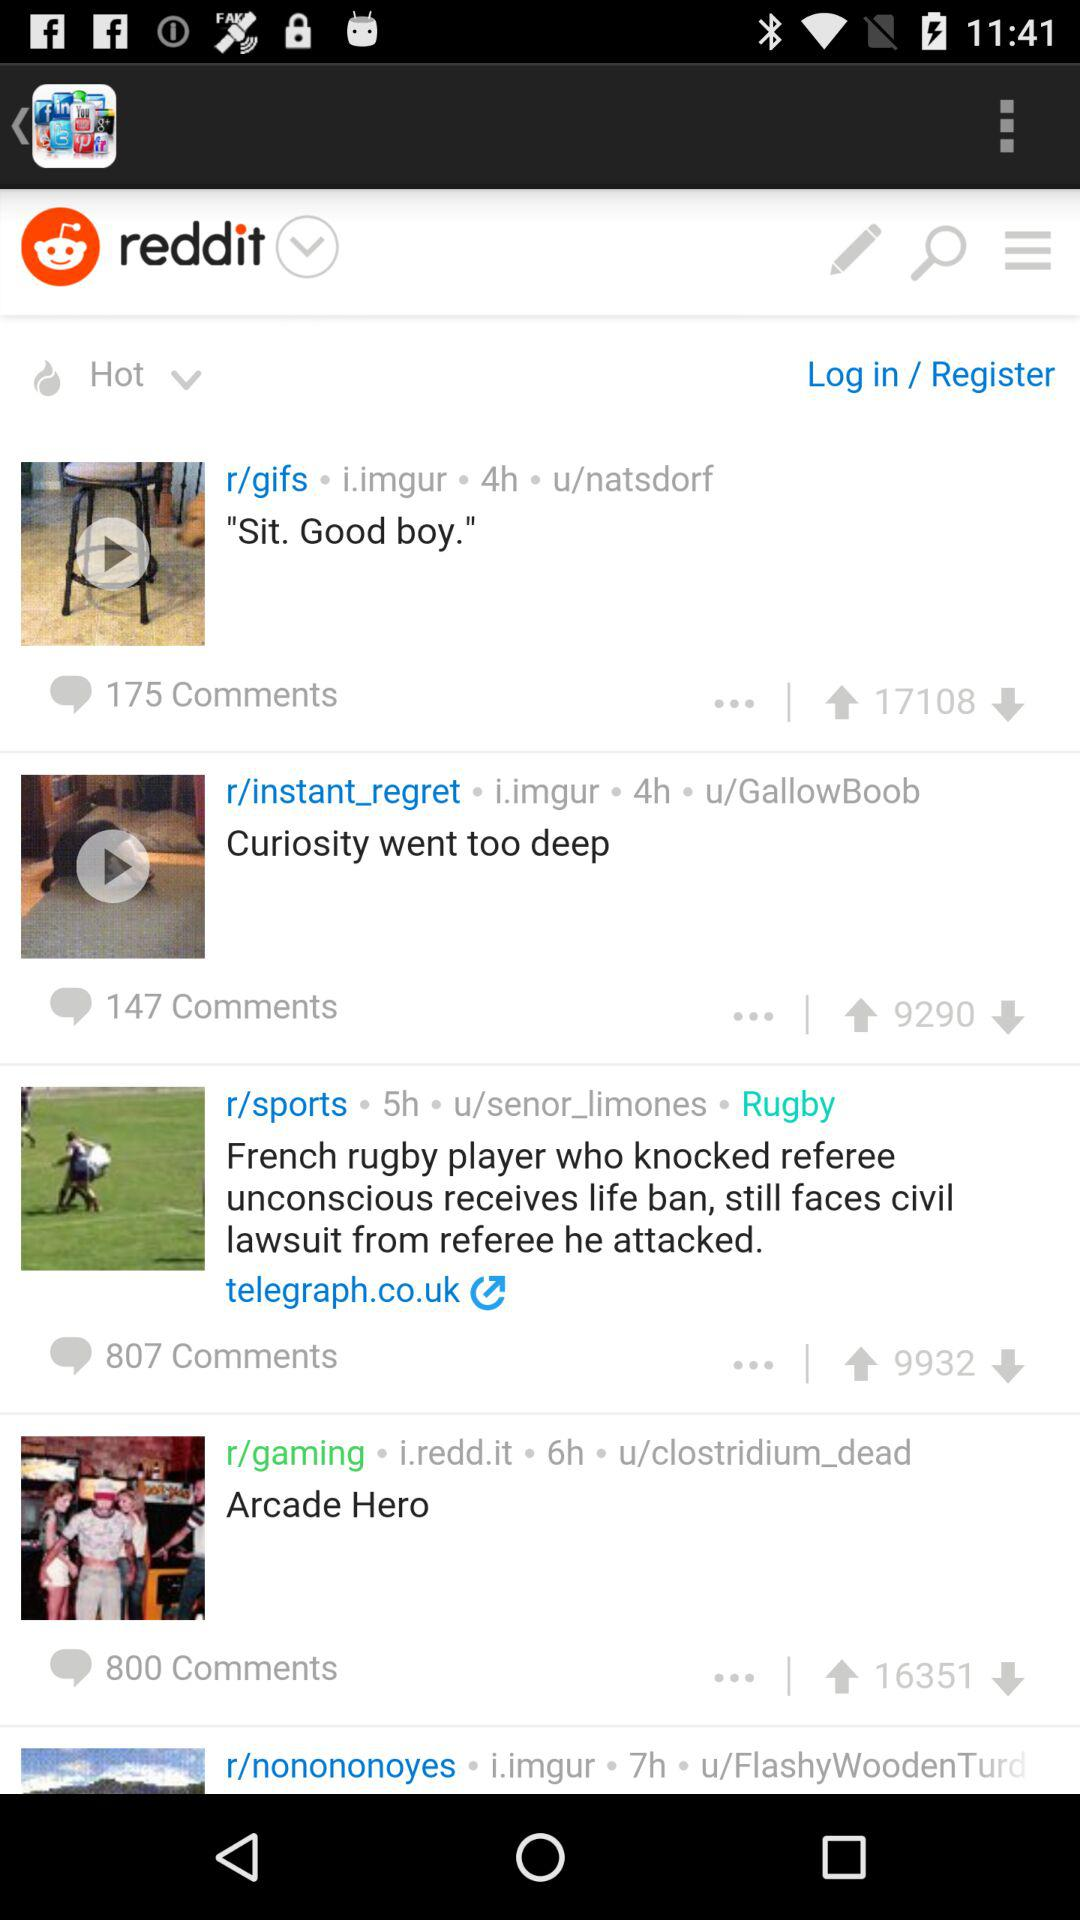What is the number of votes for the "Arcade Hero" post? The number of votes is 16351. 